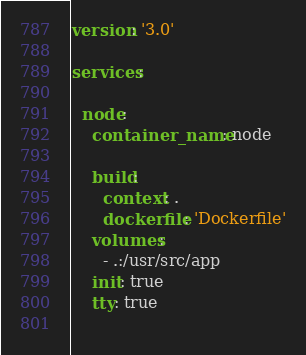<code> <loc_0><loc_0><loc_500><loc_500><_YAML_>version: '3.0'

services:

  node:
    container_name: node
    
    build:
      context: .
      dockerfile: 'Dockerfile'
    volumes:
      - .:/usr/src/app
    init: true
    tty: true
    
</code> 